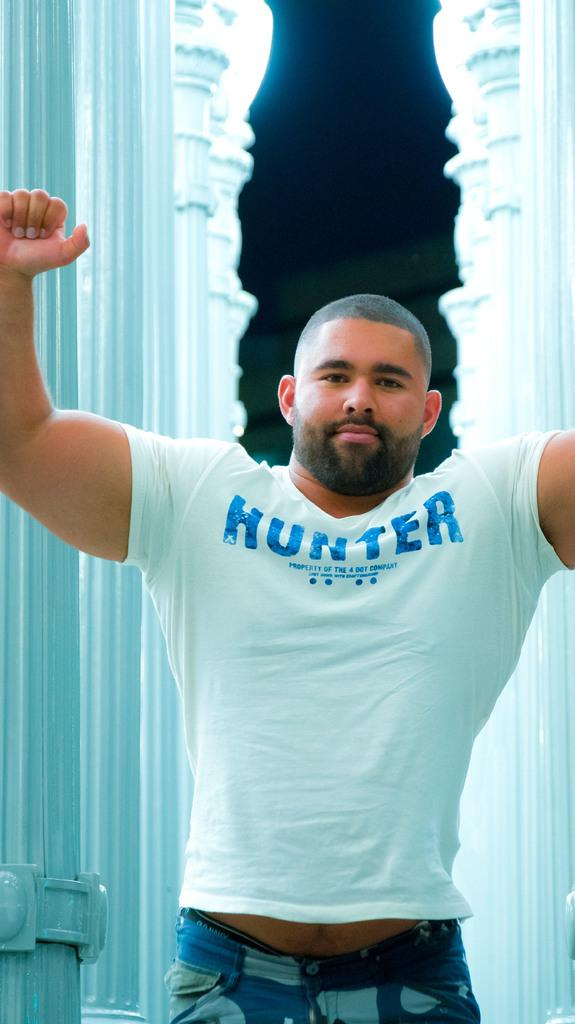What is the person in the image wearing? The person is wearing a white t-shirt. What is the person doing in the image? The person is standing. What can be seen in the background of the image? There are pillars in the background of the image. What is visible at the top of the image? The sky is visible at the top of the image. What type of illumination is present in the image? There are lights in the image. What type of grass is growing on the person's finger in the image? There is no grass or finger present in the image; the person is wearing a white t-shirt and standing. 